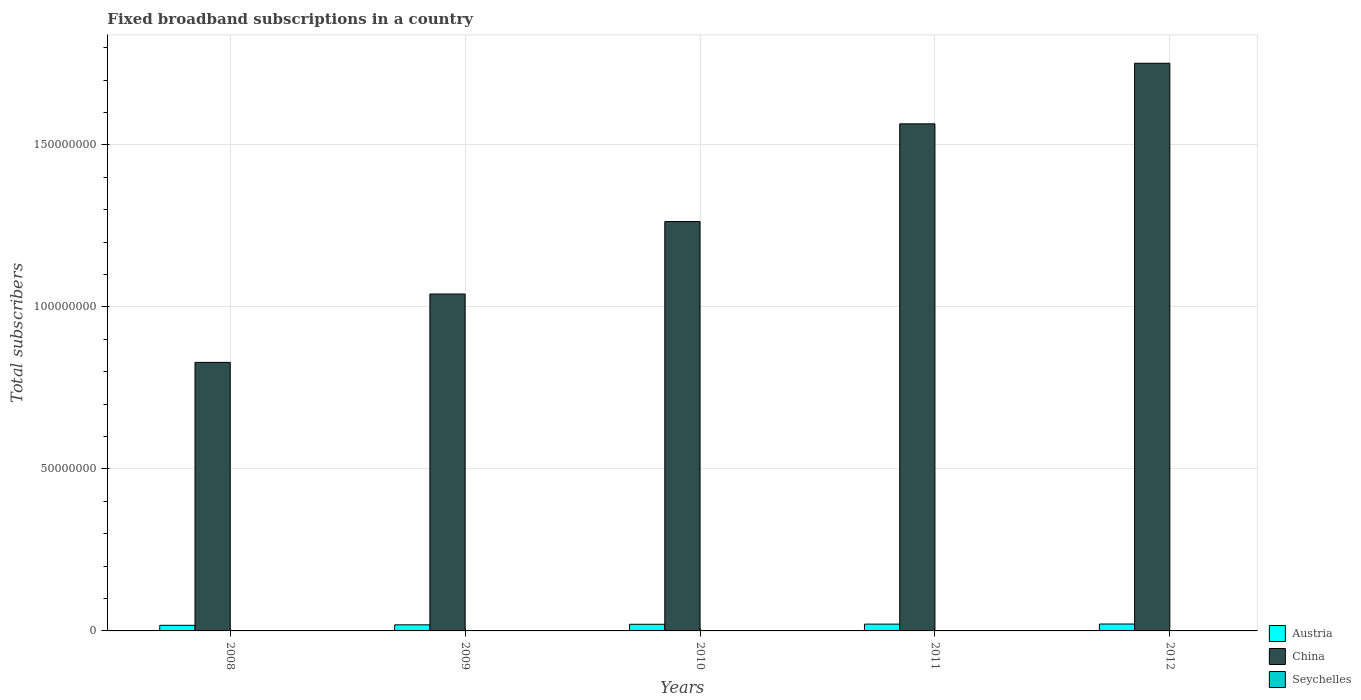How many different coloured bars are there?
Provide a short and direct response. 3. Are the number of bars per tick equal to the number of legend labels?
Make the answer very short. Yes. How many bars are there on the 1st tick from the left?
Your answer should be compact. 3. What is the label of the 3rd group of bars from the left?
Keep it short and to the point. 2010. What is the number of broadband subscriptions in Austria in 2009?
Ensure brevity in your answer.  1.88e+06. Across all years, what is the maximum number of broadband subscriptions in Austria?
Provide a succinct answer. 2.13e+06. Across all years, what is the minimum number of broadband subscriptions in Seychelles?
Provide a succinct answer. 3417. In which year was the number of broadband subscriptions in Seychelles maximum?
Offer a very short reply. 2012. In which year was the number of broadband subscriptions in Austria minimum?
Keep it short and to the point. 2008. What is the total number of broadband subscriptions in China in the graph?
Keep it short and to the point. 6.45e+08. What is the difference between the number of broadband subscriptions in Seychelles in 2008 and that in 2009?
Your answer should be compact. -1137. What is the difference between the number of broadband subscriptions in Austria in 2011 and the number of broadband subscriptions in China in 2008?
Provide a short and direct response. -8.08e+07. What is the average number of broadband subscriptions in China per year?
Provide a succinct answer. 1.29e+08. In the year 2008, what is the difference between the number of broadband subscriptions in Austria and number of broadband subscriptions in China?
Give a very brief answer. -8.12e+07. In how many years, is the number of broadband subscriptions in China greater than 120000000?
Offer a very short reply. 3. What is the ratio of the number of broadband subscriptions in Seychelles in 2008 to that in 2011?
Make the answer very short. 0.36. Is the difference between the number of broadband subscriptions in Austria in 2008 and 2009 greater than the difference between the number of broadband subscriptions in China in 2008 and 2009?
Give a very brief answer. Yes. What is the difference between the highest and the second highest number of broadband subscriptions in Seychelles?
Offer a very short reply. 1165. What is the difference between the highest and the lowest number of broadband subscriptions in China?
Offer a very short reply. 9.23e+07. Is the sum of the number of broadband subscriptions in Seychelles in 2008 and 2009 greater than the maximum number of broadband subscriptions in China across all years?
Your response must be concise. No. What does the 1st bar from the left in 2010 represents?
Your answer should be compact. Austria. What does the 2nd bar from the right in 2008 represents?
Your answer should be very brief. China. How many bars are there?
Offer a very short reply. 15. Are all the bars in the graph horizontal?
Give a very brief answer. No. How many years are there in the graph?
Ensure brevity in your answer.  5. How are the legend labels stacked?
Offer a terse response. Vertical. What is the title of the graph?
Provide a succinct answer. Fixed broadband subscriptions in a country. What is the label or title of the X-axis?
Provide a succinct answer. Years. What is the label or title of the Y-axis?
Give a very brief answer. Total subscribers. What is the Total subscribers of Austria in 2008?
Offer a very short reply. 1.73e+06. What is the Total subscribers in China in 2008?
Your answer should be very brief. 8.29e+07. What is the Total subscribers in Seychelles in 2008?
Offer a very short reply. 3417. What is the Total subscribers of Austria in 2009?
Keep it short and to the point. 1.88e+06. What is the Total subscribers in China in 2009?
Offer a very short reply. 1.04e+08. What is the Total subscribers of Seychelles in 2009?
Offer a very short reply. 4554. What is the Total subscribers of Austria in 2010?
Provide a succinct answer. 2.05e+06. What is the Total subscribers of China in 2010?
Offer a terse response. 1.26e+08. What is the Total subscribers of Seychelles in 2010?
Provide a succinct answer. 6793. What is the Total subscribers in Austria in 2011?
Your answer should be compact. 2.10e+06. What is the Total subscribers in China in 2011?
Ensure brevity in your answer.  1.56e+08. What is the Total subscribers in Seychelles in 2011?
Make the answer very short. 9412. What is the Total subscribers of Austria in 2012?
Give a very brief answer. 2.13e+06. What is the Total subscribers in China in 2012?
Your answer should be compact. 1.75e+08. What is the Total subscribers in Seychelles in 2012?
Offer a terse response. 1.06e+04. Across all years, what is the maximum Total subscribers of Austria?
Your response must be concise. 2.13e+06. Across all years, what is the maximum Total subscribers in China?
Offer a very short reply. 1.75e+08. Across all years, what is the maximum Total subscribers of Seychelles?
Offer a very short reply. 1.06e+04. Across all years, what is the minimum Total subscribers of Austria?
Your answer should be compact. 1.73e+06. Across all years, what is the minimum Total subscribers of China?
Your response must be concise. 8.29e+07. Across all years, what is the minimum Total subscribers in Seychelles?
Make the answer very short. 3417. What is the total Total subscribers of Austria in the graph?
Offer a very short reply. 9.89e+06. What is the total Total subscribers of China in the graph?
Your answer should be compact. 6.45e+08. What is the total Total subscribers of Seychelles in the graph?
Ensure brevity in your answer.  3.48e+04. What is the difference between the Total subscribers in Austria in 2008 and that in 2009?
Offer a very short reply. -1.50e+05. What is the difference between the Total subscribers in China in 2008 and that in 2009?
Your response must be concise. -2.11e+07. What is the difference between the Total subscribers in Seychelles in 2008 and that in 2009?
Provide a succinct answer. -1137. What is the difference between the Total subscribers of Austria in 2008 and that in 2010?
Provide a short and direct response. -3.21e+05. What is the difference between the Total subscribers in China in 2008 and that in 2010?
Make the answer very short. -4.35e+07. What is the difference between the Total subscribers of Seychelles in 2008 and that in 2010?
Keep it short and to the point. -3376. What is the difference between the Total subscribers of Austria in 2008 and that in 2011?
Offer a terse response. -3.69e+05. What is the difference between the Total subscribers of China in 2008 and that in 2011?
Make the answer very short. -7.36e+07. What is the difference between the Total subscribers of Seychelles in 2008 and that in 2011?
Your response must be concise. -5995. What is the difference between the Total subscribers of Austria in 2008 and that in 2012?
Keep it short and to the point. -4.01e+05. What is the difference between the Total subscribers of China in 2008 and that in 2012?
Ensure brevity in your answer.  -9.23e+07. What is the difference between the Total subscribers of Seychelles in 2008 and that in 2012?
Offer a terse response. -7160. What is the difference between the Total subscribers of Austria in 2009 and that in 2010?
Provide a succinct answer. -1.72e+05. What is the difference between the Total subscribers of China in 2009 and that in 2010?
Provide a short and direct response. -2.24e+07. What is the difference between the Total subscribers of Seychelles in 2009 and that in 2010?
Your answer should be very brief. -2239. What is the difference between the Total subscribers in Austria in 2009 and that in 2011?
Provide a succinct answer. -2.19e+05. What is the difference between the Total subscribers of China in 2009 and that in 2011?
Your answer should be very brief. -5.25e+07. What is the difference between the Total subscribers in Seychelles in 2009 and that in 2011?
Give a very brief answer. -4858. What is the difference between the Total subscribers in Austria in 2009 and that in 2012?
Your response must be concise. -2.52e+05. What is the difference between the Total subscribers of China in 2009 and that in 2012?
Make the answer very short. -7.12e+07. What is the difference between the Total subscribers in Seychelles in 2009 and that in 2012?
Provide a short and direct response. -6023. What is the difference between the Total subscribers in Austria in 2010 and that in 2011?
Provide a succinct answer. -4.73e+04. What is the difference between the Total subscribers of China in 2010 and that in 2011?
Ensure brevity in your answer.  -3.02e+07. What is the difference between the Total subscribers in Seychelles in 2010 and that in 2011?
Offer a very short reply. -2619. What is the difference between the Total subscribers in Austria in 2010 and that in 2012?
Provide a succinct answer. -7.98e+04. What is the difference between the Total subscribers of China in 2010 and that in 2012?
Provide a short and direct response. -4.88e+07. What is the difference between the Total subscribers in Seychelles in 2010 and that in 2012?
Offer a very short reply. -3784. What is the difference between the Total subscribers in Austria in 2011 and that in 2012?
Ensure brevity in your answer.  -3.25e+04. What is the difference between the Total subscribers in China in 2011 and that in 2012?
Provide a short and direct response. -1.87e+07. What is the difference between the Total subscribers in Seychelles in 2011 and that in 2012?
Offer a very short reply. -1165. What is the difference between the Total subscribers in Austria in 2008 and the Total subscribers in China in 2009?
Your answer should be very brief. -1.02e+08. What is the difference between the Total subscribers in Austria in 2008 and the Total subscribers in Seychelles in 2009?
Provide a succinct answer. 1.72e+06. What is the difference between the Total subscribers in China in 2008 and the Total subscribers in Seychelles in 2009?
Offer a very short reply. 8.29e+07. What is the difference between the Total subscribers in Austria in 2008 and the Total subscribers in China in 2010?
Offer a terse response. -1.25e+08. What is the difference between the Total subscribers of Austria in 2008 and the Total subscribers of Seychelles in 2010?
Offer a terse response. 1.72e+06. What is the difference between the Total subscribers in China in 2008 and the Total subscribers in Seychelles in 2010?
Offer a terse response. 8.29e+07. What is the difference between the Total subscribers of Austria in 2008 and the Total subscribers of China in 2011?
Give a very brief answer. -1.55e+08. What is the difference between the Total subscribers in Austria in 2008 and the Total subscribers in Seychelles in 2011?
Provide a succinct answer. 1.72e+06. What is the difference between the Total subscribers in China in 2008 and the Total subscribers in Seychelles in 2011?
Ensure brevity in your answer.  8.29e+07. What is the difference between the Total subscribers in Austria in 2008 and the Total subscribers in China in 2012?
Make the answer very short. -1.73e+08. What is the difference between the Total subscribers in Austria in 2008 and the Total subscribers in Seychelles in 2012?
Make the answer very short. 1.72e+06. What is the difference between the Total subscribers in China in 2008 and the Total subscribers in Seychelles in 2012?
Your answer should be very brief. 8.29e+07. What is the difference between the Total subscribers in Austria in 2009 and the Total subscribers in China in 2010?
Provide a short and direct response. -1.24e+08. What is the difference between the Total subscribers in Austria in 2009 and the Total subscribers in Seychelles in 2010?
Offer a terse response. 1.87e+06. What is the difference between the Total subscribers in China in 2009 and the Total subscribers in Seychelles in 2010?
Provide a succinct answer. 1.04e+08. What is the difference between the Total subscribers in Austria in 2009 and the Total subscribers in China in 2011?
Your response must be concise. -1.55e+08. What is the difference between the Total subscribers in Austria in 2009 and the Total subscribers in Seychelles in 2011?
Your answer should be compact. 1.87e+06. What is the difference between the Total subscribers in China in 2009 and the Total subscribers in Seychelles in 2011?
Offer a very short reply. 1.04e+08. What is the difference between the Total subscribers in Austria in 2009 and the Total subscribers in China in 2012?
Provide a short and direct response. -1.73e+08. What is the difference between the Total subscribers in Austria in 2009 and the Total subscribers in Seychelles in 2012?
Your answer should be very brief. 1.87e+06. What is the difference between the Total subscribers of China in 2009 and the Total subscribers of Seychelles in 2012?
Offer a very short reply. 1.04e+08. What is the difference between the Total subscribers of Austria in 2010 and the Total subscribers of China in 2011?
Make the answer very short. -1.54e+08. What is the difference between the Total subscribers in Austria in 2010 and the Total subscribers in Seychelles in 2011?
Give a very brief answer. 2.04e+06. What is the difference between the Total subscribers of China in 2010 and the Total subscribers of Seychelles in 2011?
Offer a terse response. 1.26e+08. What is the difference between the Total subscribers of Austria in 2010 and the Total subscribers of China in 2012?
Your answer should be very brief. -1.73e+08. What is the difference between the Total subscribers in Austria in 2010 and the Total subscribers in Seychelles in 2012?
Make the answer very short. 2.04e+06. What is the difference between the Total subscribers in China in 2010 and the Total subscribers in Seychelles in 2012?
Offer a terse response. 1.26e+08. What is the difference between the Total subscribers of Austria in 2011 and the Total subscribers of China in 2012?
Keep it short and to the point. -1.73e+08. What is the difference between the Total subscribers in Austria in 2011 and the Total subscribers in Seychelles in 2012?
Make the answer very short. 2.09e+06. What is the difference between the Total subscribers in China in 2011 and the Total subscribers in Seychelles in 2012?
Give a very brief answer. 1.56e+08. What is the average Total subscribers of Austria per year?
Ensure brevity in your answer.  1.98e+06. What is the average Total subscribers of China per year?
Give a very brief answer. 1.29e+08. What is the average Total subscribers in Seychelles per year?
Offer a very short reply. 6950.6. In the year 2008, what is the difference between the Total subscribers in Austria and Total subscribers in China?
Your response must be concise. -8.12e+07. In the year 2008, what is the difference between the Total subscribers in Austria and Total subscribers in Seychelles?
Keep it short and to the point. 1.73e+06. In the year 2008, what is the difference between the Total subscribers of China and Total subscribers of Seychelles?
Your response must be concise. 8.29e+07. In the year 2009, what is the difference between the Total subscribers of Austria and Total subscribers of China?
Your response must be concise. -1.02e+08. In the year 2009, what is the difference between the Total subscribers in Austria and Total subscribers in Seychelles?
Provide a succinct answer. 1.87e+06. In the year 2009, what is the difference between the Total subscribers of China and Total subscribers of Seychelles?
Provide a succinct answer. 1.04e+08. In the year 2010, what is the difference between the Total subscribers of Austria and Total subscribers of China?
Offer a terse response. -1.24e+08. In the year 2010, what is the difference between the Total subscribers in Austria and Total subscribers in Seychelles?
Make the answer very short. 2.04e+06. In the year 2010, what is the difference between the Total subscribers of China and Total subscribers of Seychelles?
Provide a short and direct response. 1.26e+08. In the year 2011, what is the difference between the Total subscribers in Austria and Total subscribers in China?
Ensure brevity in your answer.  -1.54e+08. In the year 2011, what is the difference between the Total subscribers in Austria and Total subscribers in Seychelles?
Your answer should be compact. 2.09e+06. In the year 2011, what is the difference between the Total subscribers in China and Total subscribers in Seychelles?
Offer a terse response. 1.56e+08. In the year 2012, what is the difference between the Total subscribers of Austria and Total subscribers of China?
Provide a short and direct response. -1.73e+08. In the year 2012, what is the difference between the Total subscribers of Austria and Total subscribers of Seychelles?
Offer a terse response. 2.12e+06. In the year 2012, what is the difference between the Total subscribers in China and Total subscribers in Seychelles?
Your answer should be very brief. 1.75e+08. What is the ratio of the Total subscribers of Austria in 2008 to that in 2009?
Your answer should be very brief. 0.92. What is the ratio of the Total subscribers of China in 2008 to that in 2009?
Your response must be concise. 0.8. What is the ratio of the Total subscribers of Seychelles in 2008 to that in 2009?
Ensure brevity in your answer.  0.75. What is the ratio of the Total subscribers of Austria in 2008 to that in 2010?
Your response must be concise. 0.84. What is the ratio of the Total subscribers of China in 2008 to that in 2010?
Provide a succinct answer. 0.66. What is the ratio of the Total subscribers of Seychelles in 2008 to that in 2010?
Keep it short and to the point. 0.5. What is the ratio of the Total subscribers of Austria in 2008 to that in 2011?
Ensure brevity in your answer.  0.82. What is the ratio of the Total subscribers in China in 2008 to that in 2011?
Give a very brief answer. 0.53. What is the ratio of the Total subscribers of Seychelles in 2008 to that in 2011?
Your answer should be very brief. 0.36. What is the ratio of the Total subscribers of Austria in 2008 to that in 2012?
Offer a very short reply. 0.81. What is the ratio of the Total subscribers in China in 2008 to that in 2012?
Your response must be concise. 0.47. What is the ratio of the Total subscribers in Seychelles in 2008 to that in 2012?
Provide a succinct answer. 0.32. What is the ratio of the Total subscribers in Austria in 2009 to that in 2010?
Offer a terse response. 0.92. What is the ratio of the Total subscribers in China in 2009 to that in 2010?
Ensure brevity in your answer.  0.82. What is the ratio of the Total subscribers in Seychelles in 2009 to that in 2010?
Your answer should be very brief. 0.67. What is the ratio of the Total subscribers of Austria in 2009 to that in 2011?
Keep it short and to the point. 0.9. What is the ratio of the Total subscribers in China in 2009 to that in 2011?
Offer a very short reply. 0.66. What is the ratio of the Total subscribers of Seychelles in 2009 to that in 2011?
Offer a very short reply. 0.48. What is the ratio of the Total subscribers in Austria in 2009 to that in 2012?
Your response must be concise. 0.88. What is the ratio of the Total subscribers in China in 2009 to that in 2012?
Ensure brevity in your answer.  0.59. What is the ratio of the Total subscribers in Seychelles in 2009 to that in 2012?
Make the answer very short. 0.43. What is the ratio of the Total subscribers in Austria in 2010 to that in 2011?
Offer a terse response. 0.98. What is the ratio of the Total subscribers in China in 2010 to that in 2011?
Provide a short and direct response. 0.81. What is the ratio of the Total subscribers of Seychelles in 2010 to that in 2011?
Provide a succinct answer. 0.72. What is the ratio of the Total subscribers in Austria in 2010 to that in 2012?
Provide a short and direct response. 0.96. What is the ratio of the Total subscribers in China in 2010 to that in 2012?
Your answer should be compact. 0.72. What is the ratio of the Total subscribers of Seychelles in 2010 to that in 2012?
Your answer should be compact. 0.64. What is the ratio of the Total subscribers in Austria in 2011 to that in 2012?
Provide a short and direct response. 0.98. What is the ratio of the Total subscribers in China in 2011 to that in 2012?
Ensure brevity in your answer.  0.89. What is the ratio of the Total subscribers of Seychelles in 2011 to that in 2012?
Your answer should be compact. 0.89. What is the difference between the highest and the second highest Total subscribers in Austria?
Make the answer very short. 3.25e+04. What is the difference between the highest and the second highest Total subscribers in China?
Ensure brevity in your answer.  1.87e+07. What is the difference between the highest and the second highest Total subscribers of Seychelles?
Your response must be concise. 1165. What is the difference between the highest and the lowest Total subscribers in Austria?
Provide a succinct answer. 4.01e+05. What is the difference between the highest and the lowest Total subscribers in China?
Make the answer very short. 9.23e+07. What is the difference between the highest and the lowest Total subscribers of Seychelles?
Make the answer very short. 7160. 